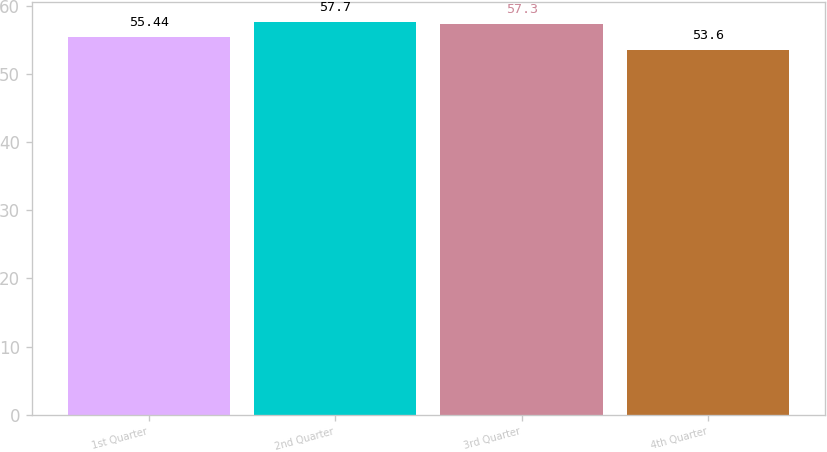Convert chart to OTSL. <chart><loc_0><loc_0><loc_500><loc_500><bar_chart><fcel>1st Quarter<fcel>2nd Quarter<fcel>3rd Quarter<fcel>4th Quarter<nl><fcel>55.44<fcel>57.7<fcel>57.3<fcel>53.6<nl></chart> 